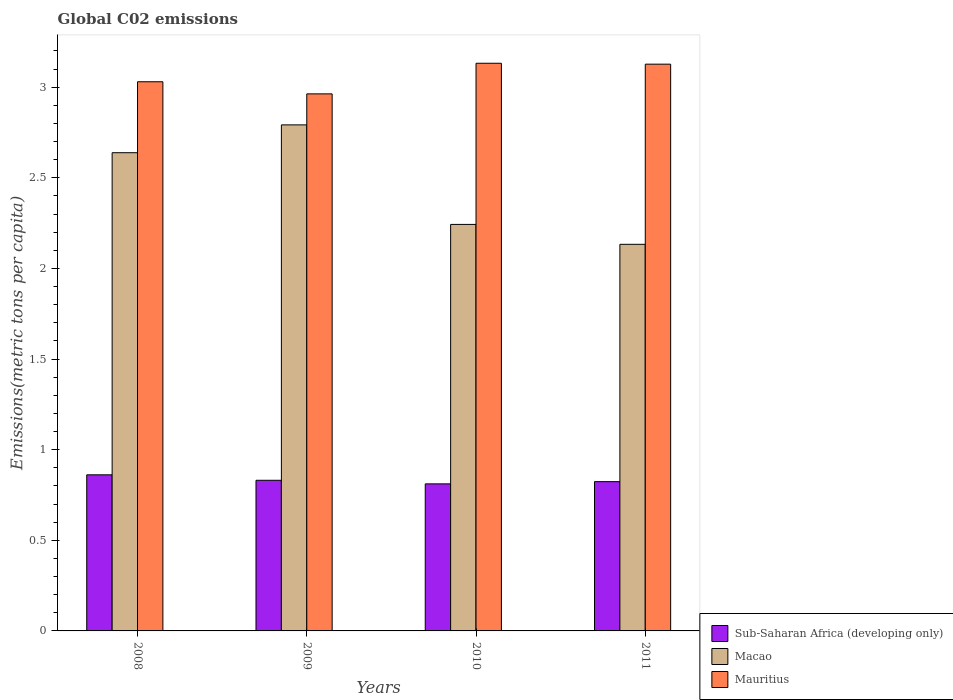Are the number of bars on each tick of the X-axis equal?
Give a very brief answer. Yes. What is the amount of CO2 emitted in in Mauritius in 2009?
Offer a very short reply. 2.96. Across all years, what is the maximum amount of CO2 emitted in in Mauritius?
Offer a terse response. 3.13. Across all years, what is the minimum amount of CO2 emitted in in Sub-Saharan Africa (developing only)?
Offer a terse response. 0.81. In which year was the amount of CO2 emitted in in Sub-Saharan Africa (developing only) maximum?
Offer a terse response. 2008. In which year was the amount of CO2 emitted in in Sub-Saharan Africa (developing only) minimum?
Keep it short and to the point. 2010. What is the total amount of CO2 emitted in in Macao in the graph?
Give a very brief answer. 9.81. What is the difference between the amount of CO2 emitted in in Mauritius in 2010 and that in 2011?
Your answer should be compact. 0.01. What is the difference between the amount of CO2 emitted in in Mauritius in 2011 and the amount of CO2 emitted in in Sub-Saharan Africa (developing only) in 2010?
Give a very brief answer. 2.32. What is the average amount of CO2 emitted in in Sub-Saharan Africa (developing only) per year?
Your answer should be very brief. 0.83. In the year 2011, what is the difference between the amount of CO2 emitted in in Mauritius and amount of CO2 emitted in in Sub-Saharan Africa (developing only)?
Provide a short and direct response. 2.3. In how many years, is the amount of CO2 emitted in in Mauritius greater than 1.2 metric tons per capita?
Ensure brevity in your answer.  4. What is the ratio of the amount of CO2 emitted in in Sub-Saharan Africa (developing only) in 2010 to that in 2011?
Your response must be concise. 0.99. Is the difference between the amount of CO2 emitted in in Mauritius in 2009 and 2011 greater than the difference between the amount of CO2 emitted in in Sub-Saharan Africa (developing only) in 2009 and 2011?
Give a very brief answer. No. What is the difference between the highest and the second highest amount of CO2 emitted in in Mauritius?
Keep it short and to the point. 0.01. What is the difference between the highest and the lowest amount of CO2 emitted in in Macao?
Provide a succinct answer. 0.66. What does the 2nd bar from the left in 2008 represents?
Give a very brief answer. Macao. What does the 2nd bar from the right in 2009 represents?
Your answer should be compact. Macao. How many bars are there?
Your answer should be compact. 12. How many years are there in the graph?
Offer a very short reply. 4. Does the graph contain any zero values?
Provide a short and direct response. No. Where does the legend appear in the graph?
Your response must be concise. Bottom right. How are the legend labels stacked?
Ensure brevity in your answer.  Vertical. What is the title of the graph?
Ensure brevity in your answer.  Global C02 emissions. Does "Denmark" appear as one of the legend labels in the graph?
Your response must be concise. No. What is the label or title of the Y-axis?
Ensure brevity in your answer.  Emissions(metric tons per capita). What is the Emissions(metric tons per capita) of Sub-Saharan Africa (developing only) in 2008?
Ensure brevity in your answer.  0.86. What is the Emissions(metric tons per capita) of Macao in 2008?
Your answer should be compact. 2.64. What is the Emissions(metric tons per capita) in Mauritius in 2008?
Provide a succinct answer. 3.03. What is the Emissions(metric tons per capita) of Sub-Saharan Africa (developing only) in 2009?
Provide a succinct answer. 0.83. What is the Emissions(metric tons per capita) of Macao in 2009?
Keep it short and to the point. 2.79. What is the Emissions(metric tons per capita) in Mauritius in 2009?
Provide a succinct answer. 2.96. What is the Emissions(metric tons per capita) of Sub-Saharan Africa (developing only) in 2010?
Provide a short and direct response. 0.81. What is the Emissions(metric tons per capita) of Macao in 2010?
Provide a short and direct response. 2.24. What is the Emissions(metric tons per capita) in Mauritius in 2010?
Keep it short and to the point. 3.13. What is the Emissions(metric tons per capita) in Sub-Saharan Africa (developing only) in 2011?
Make the answer very short. 0.82. What is the Emissions(metric tons per capita) of Macao in 2011?
Offer a terse response. 2.13. What is the Emissions(metric tons per capita) of Mauritius in 2011?
Give a very brief answer. 3.13. Across all years, what is the maximum Emissions(metric tons per capita) in Sub-Saharan Africa (developing only)?
Your response must be concise. 0.86. Across all years, what is the maximum Emissions(metric tons per capita) in Macao?
Provide a succinct answer. 2.79. Across all years, what is the maximum Emissions(metric tons per capita) of Mauritius?
Provide a short and direct response. 3.13. Across all years, what is the minimum Emissions(metric tons per capita) of Sub-Saharan Africa (developing only)?
Offer a very short reply. 0.81. Across all years, what is the minimum Emissions(metric tons per capita) of Macao?
Provide a short and direct response. 2.13. Across all years, what is the minimum Emissions(metric tons per capita) of Mauritius?
Keep it short and to the point. 2.96. What is the total Emissions(metric tons per capita) of Sub-Saharan Africa (developing only) in the graph?
Provide a short and direct response. 3.33. What is the total Emissions(metric tons per capita) in Macao in the graph?
Provide a short and direct response. 9.81. What is the total Emissions(metric tons per capita) of Mauritius in the graph?
Keep it short and to the point. 12.25. What is the difference between the Emissions(metric tons per capita) in Sub-Saharan Africa (developing only) in 2008 and that in 2009?
Keep it short and to the point. 0.03. What is the difference between the Emissions(metric tons per capita) in Macao in 2008 and that in 2009?
Make the answer very short. -0.15. What is the difference between the Emissions(metric tons per capita) in Mauritius in 2008 and that in 2009?
Your answer should be very brief. 0.07. What is the difference between the Emissions(metric tons per capita) in Sub-Saharan Africa (developing only) in 2008 and that in 2010?
Make the answer very short. 0.05. What is the difference between the Emissions(metric tons per capita) in Macao in 2008 and that in 2010?
Provide a short and direct response. 0.4. What is the difference between the Emissions(metric tons per capita) in Mauritius in 2008 and that in 2010?
Your response must be concise. -0.1. What is the difference between the Emissions(metric tons per capita) in Sub-Saharan Africa (developing only) in 2008 and that in 2011?
Offer a terse response. 0.04. What is the difference between the Emissions(metric tons per capita) of Macao in 2008 and that in 2011?
Your response must be concise. 0.51. What is the difference between the Emissions(metric tons per capita) of Mauritius in 2008 and that in 2011?
Ensure brevity in your answer.  -0.1. What is the difference between the Emissions(metric tons per capita) of Sub-Saharan Africa (developing only) in 2009 and that in 2010?
Make the answer very short. 0.02. What is the difference between the Emissions(metric tons per capita) in Macao in 2009 and that in 2010?
Keep it short and to the point. 0.55. What is the difference between the Emissions(metric tons per capita) in Mauritius in 2009 and that in 2010?
Your answer should be compact. -0.17. What is the difference between the Emissions(metric tons per capita) in Sub-Saharan Africa (developing only) in 2009 and that in 2011?
Your response must be concise. 0.01. What is the difference between the Emissions(metric tons per capita) in Macao in 2009 and that in 2011?
Provide a succinct answer. 0.66. What is the difference between the Emissions(metric tons per capita) in Mauritius in 2009 and that in 2011?
Your answer should be compact. -0.16. What is the difference between the Emissions(metric tons per capita) of Sub-Saharan Africa (developing only) in 2010 and that in 2011?
Offer a very short reply. -0.01. What is the difference between the Emissions(metric tons per capita) of Macao in 2010 and that in 2011?
Your answer should be very brief. 0.11. What is the difference between the Emissions(metric tons per capita) in Mauritius in 2010 and that in 2011?
Your answer should be very brief. 0.01. What is the difference between the Emissions(metric tons per capita) in Sub-Saharan Africa (developing only) in 2008 and the Emissions(metric tons per capita) in Macao in 2009?
Your response must be concise. -1.93. What is the difference between the Emissions(metric tons per capita) in Sub-Saharan Africa (developing only) in 2008 and the Emissions(metric tons per capita) in Mauritius in 2009?
Offer a very short reply. -2.1. What is the difference between the Emissions(metric tons per capita) of Macao in 2008 and the Emissions(metric tons per capita) of Mauritius in 2009?
Provide a short and direct response. -0.32. What is the difference between the Emissions(metric tons per capita) of Sub-Saharan Africa (developing only) in 2008 and the Emissions(metric tons per capita) of Macao in 2010?
Your answer should be compact. -1.38. What is the difference between the Emissions(metric tons per capita) in Sub-Saharan Africa (developing only) in 2008 and the Emissions(metric tons per capita) in Mauritius in 2010?
Ensure brevity in your answer.  -2.27. What is the difference between the Emissions(metric tons per capita) of Macao in 2008 and the Emissions(metric tons per capita) of Mauritius in 2010?
Ensure brevity in your answer.  -0.49. What is the difference between the Emissions(metric tons per capita) in Sub-Saharan Africa (developing only) in 2008 and the Emissions(metric tons per capita) in Macao in 2011?
Offer a very short reply. -1.27. What is the difference between the Emissions(metric tons per capita) of Sub-Saharan Africa (developing only) in 2008 and the Emissions(metric tons per capita) of Mauritius in 2011?
Keep it short and to the point. -2.27. What is the difference between the Emissions(metric tons per capita) in Macao in 2008 and the Emissions(metric tons per capita) in Mauritius in 2011?
Your answer should be compact. -0.49. What is the difference between the Emissions(metric tons per capita) of Sub-Saharan Africa (developing only) in 2009 and the Emissions(metric tons per capita) of Macao in 2010?
Give a very brief answer. -1.41. What is the difference between the Emissions(metric tons per capita) in Sub-Saharan Africa (developing only) in 2009 and the Emissions(metric tons per capita) in Mauritius in 2010?
Provide a succinct answer. -2.3. What is the difference between the Emissions(metric tons per capita) of Macao in 2009 and the Emissions(metric tons per capita) of Mauritius in 2010?
Your response must be concise. -0.34. What is the difference between the Emissions(metric tons per capita) in Sub-Saharan Africa (developing only) in 2009 and the Emissions(metric tons per capita) in Macao in 2011?
Provide a short and direct response. -1.3. What is the difference between the Emissions(metric tons per capita) in Sub-Saharan Africa (developing only) in 2009 and the Emissions(metric tons per capita) in Mauritius in 2011?
Ensure brevity in your answer.  -2.3. What is the difference between the Emissions(metric tons per capita) in Macao in 2009 and the Emissions(metric tons per capita) in Mauritius in 2011?
Provide a succinct answer. -0.34. What is the difference between the Emissions(metric tons per capita) in Sub-Saharan Africa (developing only) in 2010 and the Emissions(metric tons per capita) in Macao in 2011?
Your answer should be very brief. -1.32. What is the difference between the Emissions(metric tons per capita) in Sub-Saharan Africa (developing only) in 2010 and the Emissions(metric tons per capita) in Mauritius in 2011?
Make the answer very short. -2.32. What is the difference between the Emissions(metric tons per capita) of Macao in 2010 and the Emissions(metric tons per capita) of Mauritius in 2011?
Give a very brief answer. -0.88. What is the average Emissions(metric tons per capita) in Sub-Saharan Africa (developing only) per year?
Offer a terse response. 0.83. What is the average Emissions(metric tons per capita) in Macao per year?
Ensure brevity in your answer.  2.45. What is the average Emissions(metric tons per capita) in Mauritius per year?
Make the answer very short. 3.06. In the year 2008, what is the difference between the Emissions(metric tons per capita) of Sub-Saharan Africa (developing only) and Emissions(metric tons per capita) of Macao?
Keep it short and to the point. -1.78. In the year 2008, what is the difference between the Emissions(metric tons per capita) of Sub-Saharan Africa (developing only) and Emissions(metric tons per capita) of Mauritius?
Your answer should be compact. -2.17. In the year 2008, what is the difference between the Emissions(metric tons per capita) of Macao and Emissions(metric tons per capita) of Mauritius?
Make the answer very short. -0.39. In the year 2009, what is the difference between the Emissions(metric tons per capita) in Sub-Saharan Africa (developing only) and Emissions(metric tons per capita) in Macao?
Keep it short and to the point. -1.96. In the year 2009, what is the difference between the Emissions(metric tons per capita) of Sub-Saharan Africa (developing only) and Emissions(metric tons per capita) of Mauritius?
Keep it short and to the point. -2.13. In the year 2009, what is the difference between the Emissions(metric tons per capita) in Macao and Emissions(metric tons per capita) in Mauritius?
Your answer should be very brief. -0.17. In the year 2010, what is the difference between the Emissions(metric tons per capita) of Sub-Saharan Africa (developing only) and Emissions(metric tons per capita) of Macao?
Make the answer very short. -1.43. In the year 2010, what is the difference between the Emissions(metric tons per capita) in Sub-Saharan Africa (developing only) and Emissions(metric tons per capita) in Mauritius?
Offer a terse response. -2.32. In the year 2010, what is the difference between the Emissions(metric tons per capita) in Macao and Emissions(metric tons per capita) in Mauritius?
Make the answer very short. -0.89. In the year 2011, what is the difference between the Emissions(metric tons per capita) of Sub-Saharan Africa (developing only) and Emissions(metric tons per capita) of Macao?
Offer a very short reply. -1.31. In the year 2011, what is the difference between the Emissions(metric tons per capita) in Sub-Saharan Africa (developing only) and Emissions(metric tons per capita) in Mauritius?
Provide a short and direct response. -2.3. In the year 2011, what is the difference between the Emissions(metric tons per capita) of Macao and Emissions(metric tons per capita) of Mauritius?
Keep it short and to the point. -0.99. What is the ratio of the Emissions(metric tons per capita) in Sub-Saharan Africa (developing only) in 2008 to that in 2009?
Your answer should be compact. 1.04. What is the ratio of the Emissions(metric tons per capita) of Macao in 2008 to that in 2009?
Your response must be concise. 0.94. What is the ratio of the Emissions(metric tons per capita) of Mauritius in 2008 to that in 2009?
Give a very brief answer. 1.02. What is the ratio of the Emissions(metric tons per capita) in Sub-Saharan Africa (developing only) in 2008 to that in 2010?
Provide a short and direct response. 1.06. What is the ratio of the Emissions(metric tons per capita) in Macao in 2008 to that in 2010?
Your answer should be very brief. 1.18. What is the ratio of the Emissions(metric tons per capita) of Mauritius in 2008 to that in 2010?
Make the answer very short. 0.97. What is the ratio of the Emissions(metric tons per capita) of Sub-Saharan Africa (developing only) in 2008 to that in 2011?
Ensure brevity in your answer.  1.05. What is the ratio of the Emissions(metric tons per capita) of Macao in 2008 to that in 2011?
Your answer should be compact. 1.24. What is the ratio of the Emissions(metric tons per capita) in Mauritius in 2008 to that in 2011?
Give a very brief answer. 0.97. What is the ratio of the Emissions(metric tons per capita) in Sub-Saharan Africa (developing only) in 2009 to that in 2010?
Keep it short and to the point. 1.02. What is the ratio of the Emissions(metric tons per capita) of Macao in 2009 to that in 2010?
Make the answer very short. 1.24. What is the ratio of the Emissions(metric tons per capita) of Mauritius in 2009 to that in 2010?
Offer a very short reply. 0.95. What is the ratio of the Emissions(metric tons per capita) in Sub-Saharan Africa (developing only) in 2009 to that in 2011?
Keep it short and to the point. 1.01. What is the ratio of the Emissions(metric tons per capita) in Macao in 2009 to that in 2011?
Keep it short and to the point. 1.31. What is the ratio of the Emissions(metric tons per capita) in Mauritius in 2009 to that in 2011?
Ensure brevity in your answer.  0.95. What is the ratio of the Emissions(metric tons per capita) of Sub-Saharan Africa (developing only) in 2010 to that in 2011?
Your answer should be very brief. 0.99. What is the ratio of the Emissions(metric tons per capita) of Macao in 2010 to that in 2011?
Keep it short and to the point. 1.05. What is the ratio of the Emissions(metric tons per capita) of Mauritius in 2010 to that in 2011?
Offer a very short reply. 1. What is the difference between the highest and the second highest Emissions(metric tons per capita) in Sub-Saharan Africa (developing only)?
Keep it short and to the point. 0.03. What is the difference between the highest and the second highest Emissions(metric tons per capita) of Macao?
Your answer should be compact. 0.15. What is the difference between the highest and the second highest Emissions(metric tons per capita) in Mauritius?
Provide a short and direct response. 0.01. What is the difference between the highest and the lowest Emissions(metric tons per capita) in Sub-Saharan Africa (developing only)?
Keep it short and to the point. 0.05. What is the difference between the highest and the lowest Emissions(metric tons per capita) in Macao?
Keep it short and to the point. 0.66. What is the difference between the highest and the lowest Emissions(metric tons per capita) of Mauritius?
Offer a very short reply. 0.17. 